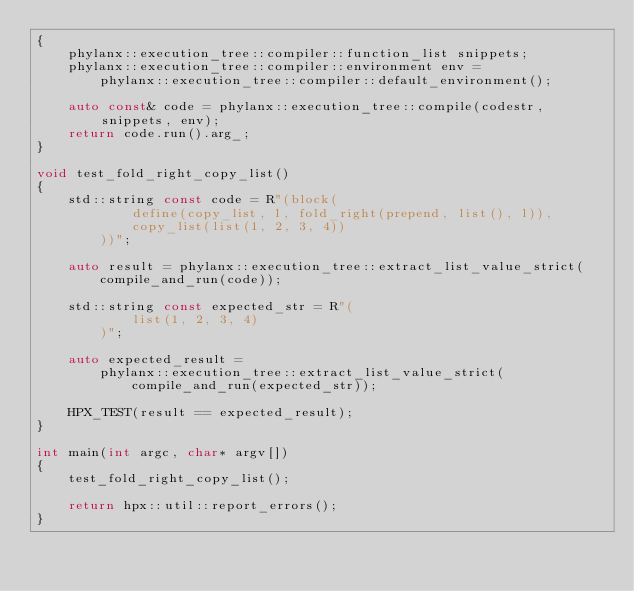<code> <loc_0><loc_0><loc_500><loc_500><_C++_>{
    phylanx::execution_tree::compiler::function_list snippets;
    phylanx::execution_tree::compiler::environment env =
        phylanx::execution_tree::compiler::default_environment();

    auto const& code = phylanx::execution_tree::compile(codestr, snippets, env);
    return code.run().arg_;
}

void test_fold_right_copy_list()
{
    std::string const code = R"(block(
            define(copy_list, l, fold_right(prepend, list(), l)),
            copy_list(list(1, 2, 3, 4))
        ))";

    auto result = phylanx::execution_tree::extract_list_value_strict(
        compile_and_run(code));

    std::string const expected_str = R"(
            list(1, 2, 3, 4)
        )";

    auto expected_result =
        phylanx::execution_tree::extract_list_value_strict(
            compile_and_run(expected_str));

    HPX_TEST(result == expected_result);
}

int main(int argc, char* argv[])
{
    test_fold_right_copy_list();

    return hpx::util::report_errors();
}
</code> 